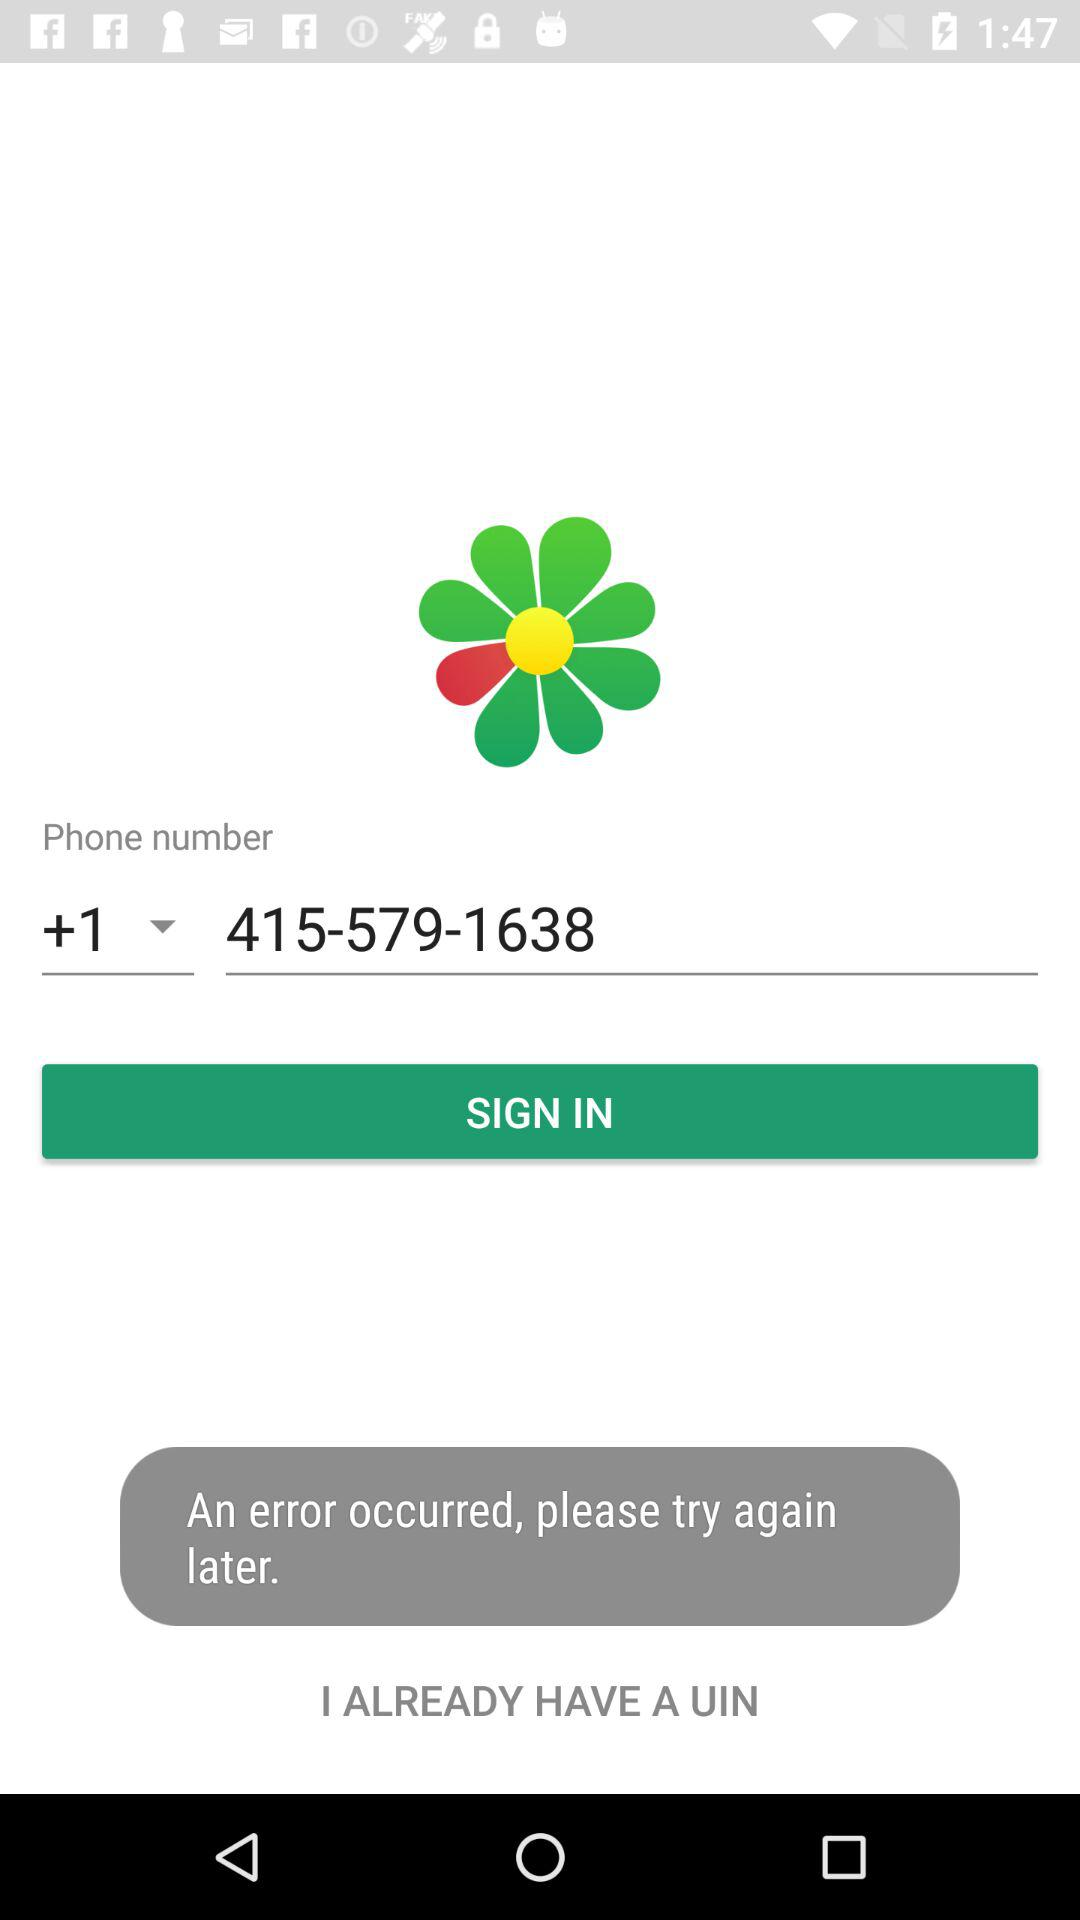What is the phone number available on the screen? The phone number available on the screen is +1 415-579-1638. 